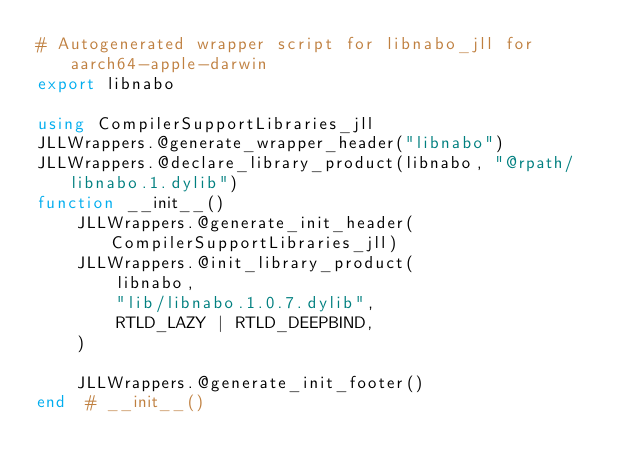<code> <loc_0><loc_0><loc_500><loc_500><_Julia_># Autogenerated wrapper script for libnabo_jll for aarch64-apple-darwin
export libnabo

using CompilerSupportLibraries_jll
JLLWrappers.@generate_wrapper_header("libnabo")
JLLWrappers.@declare_library_product(libnabo, "@rpath/libnabo.1.dylib")
function __init__()
    JLLWrappers.@generate_init_header(CompilerSupportLibraries_jll)
    JLLWrappers.@init_library_product(
        libnabo,
        "lib/libnabo.1.0.7.dylib",
        RTLD_LAZY | RTLD_DEEPBIND,
    )

    JLLWrappers.@generate_init_footer()
end  # __init__()
</code> 